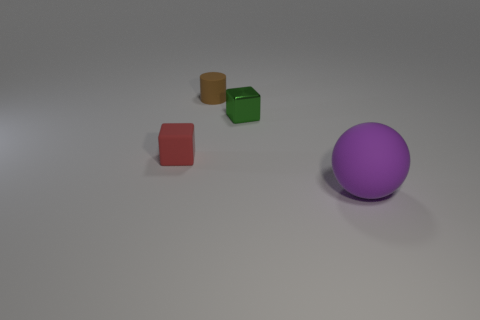Add 1 brown matte things. How many objects exist? 5 Subtract all balls. How many objects are left? 3 Subtract all purple spheres. Subtract all red cubes. How many objects are left? 2 Add 3 small green objects. How many small green objects are left? 4 Add 3 big cyan metal spheres. How many big cyan metal spheres exist? 3 Subtract 1 green cubes. How many objects are left? 3 